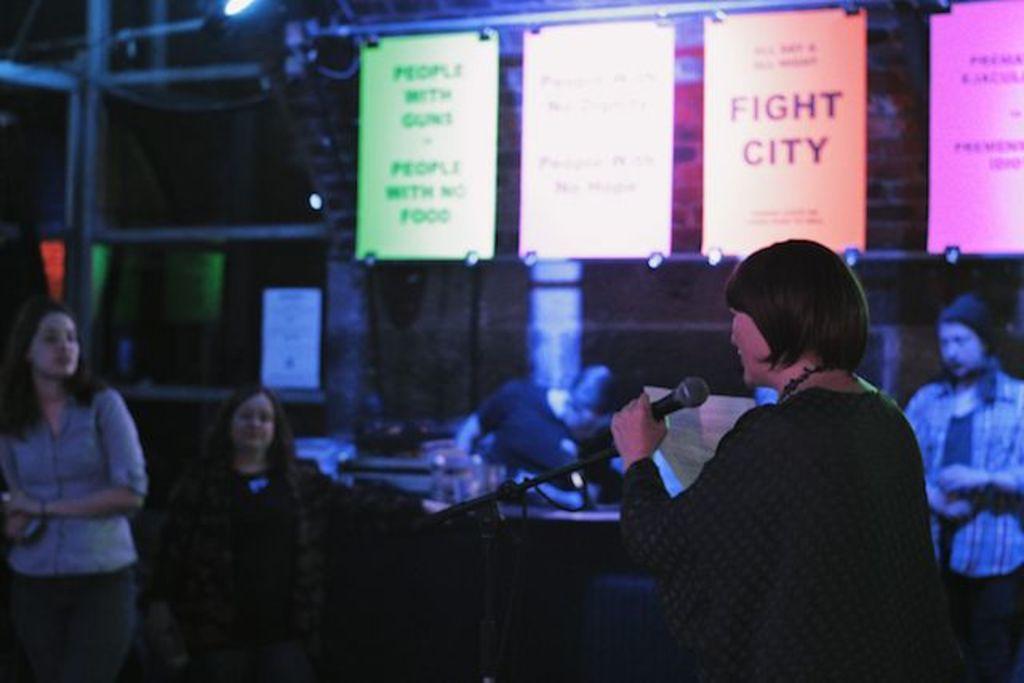Could you give a brief overview of what you see in this image? This is an image clicked in the dark. On the right side I can see a woman standing and holding a mike in the hand. In the background there are some people are standing and looking at this woman. On the top of the image I can see some posts are hanging to a metal rod. 